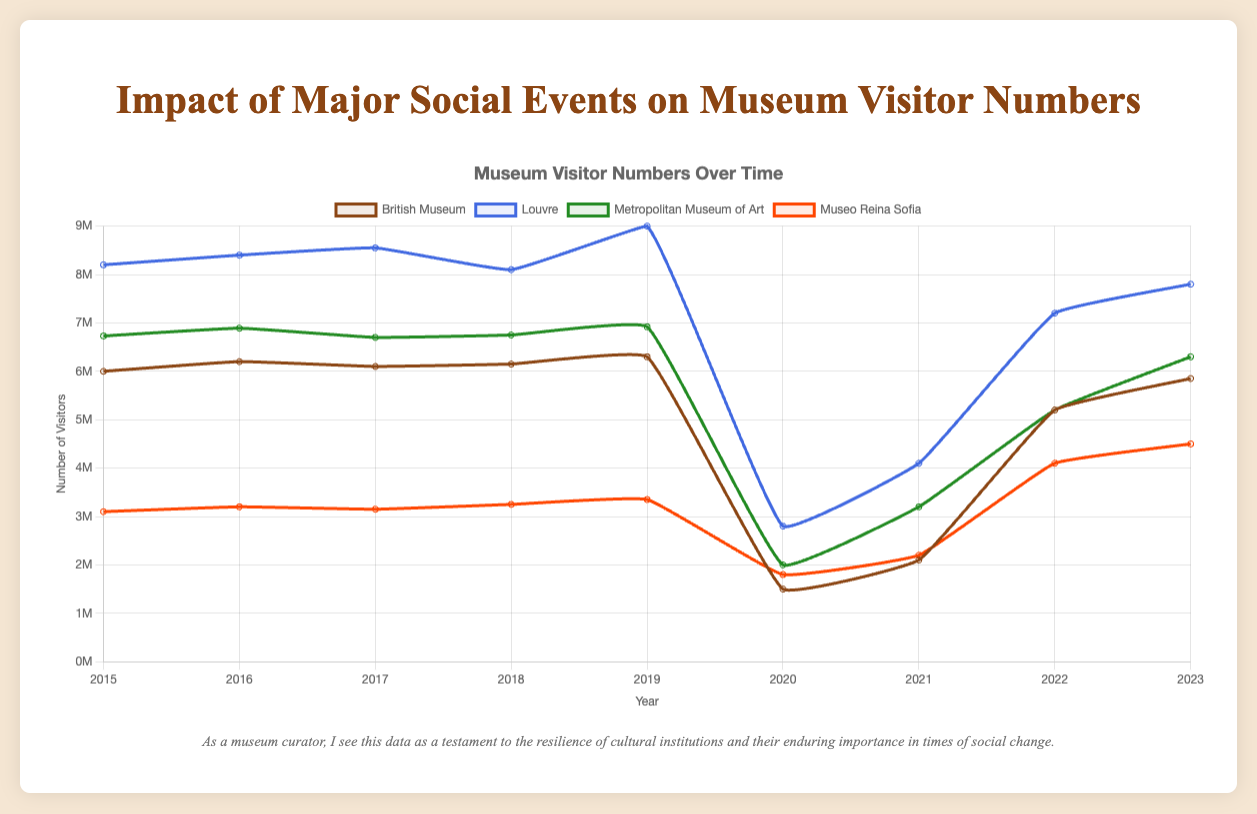What's the trend of visitor numbers at the Louvre from 2015 to 2023? The visitor numbers at the Louvre increased from 8.2 million in 2015 to 9 million in 2019, followed by a sharp decline during the COVID-19 pandemic (2.8 million in 2020). The numbers then recovered to 7.2 million in 2022 and slightly increased again to 7.8 million in 2023.
Answer: Increasing, then decreasing sharply during the pandemic, and partially recovering afterward In which year did the British Museum experience the highest number of visitors? The British Museum had the highest number of visitors in 2019 with 6.3 million visitors.
Answer: 2019 How did the visitor numbers of the Museo Reina Sofia change from 2020 to 2021? During the COVID-19 pandemic in 2020, the visitor numbers were 1.8 million. They slightly increased to 2.2 million in 2021.
Answer: Increased Which event had the most significant drop in visitors across all museums? The COVID-19 pandemic in 2020 had the most significant drop in visitors, with reductions across all listed museums.
Answer: COVID-19 pandemic How does the visitor number trend of the Metropolitan Museum of Art from 2015 to 2023 compare to that of the British Museum? Both museums saw an initial increase in visitor numbers until 2019. During the COVID-19 pandemic, both experienced a sharp decline in 2020 followed by a gradual recovery. By 2023, the Metropolitan Museum of Art recovered to 6.3 million visitors, whereas the British Museum recovered to 5.85 million visitors.
Answer: Similar trends with slight differences in recovery rates What is the average visitor number of the Louvre over the years 2015 to 2023? Sum the visitor numbers from 2015 to 2023 (8.2 + 8.4 + 8.55 + 8.1 + 9 + 2.8 + 4.1 + 7.2 + 7.8) = 64.15 million. Divide by the number of years (9), the average is 64.15 / 9 ≈ 7.128 million.
Answer: 7.128 million Which social event in the chart is associated with the highest recorded visitor numbers at any museum? The "Hong Kong Protests" in 2019 are associated with the highest recorded visitor numbers at the Louvre, with 9 million visitors.
Answer: Hong Kong Protests During which years did the visitor numbers for the British Museum remain relatively stable? The British Museum's visitor numbers remained relatively stable between 2015 and 2019, ranging from 6 million to 6.3 million visitors before sharply declining in 2020.
Answer: 2015-2019 Compare the visitor numbers at the Louvre and the Museo Reina Sofia in 2023. In 2023, the Louvre had 7.8 million visitors, while the Museo Reina Sofia had 4.5 million visitors, indicating that the Louvre had more visitors.
Answer: Louvre had more visitors Which years reflect the impact of the Brexit Referendum on museum visitor numbers? The Brexit Referendum occurred in 2016, so visitor numbers in 2016 and subsequent years (2017 and beyond) reflect its impact. There were slight increases in visitor numbers at all museums from 2016 to 2017.
Answer: 2016 and beyond 